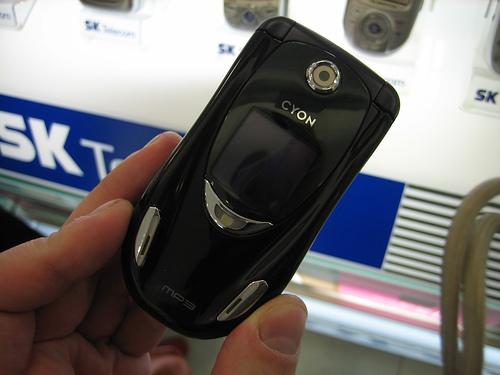Is this a keyboard mouse?
Concise answer only. No. What is he holding?
Short answer required. Cell phone. What brand is this cell phone?
Concise answer only. Cyon. 